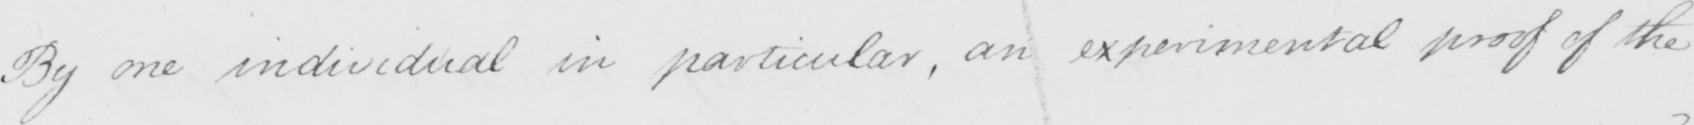What text is written in this handwritten line? By one individual in particular , an experimental proof of the 